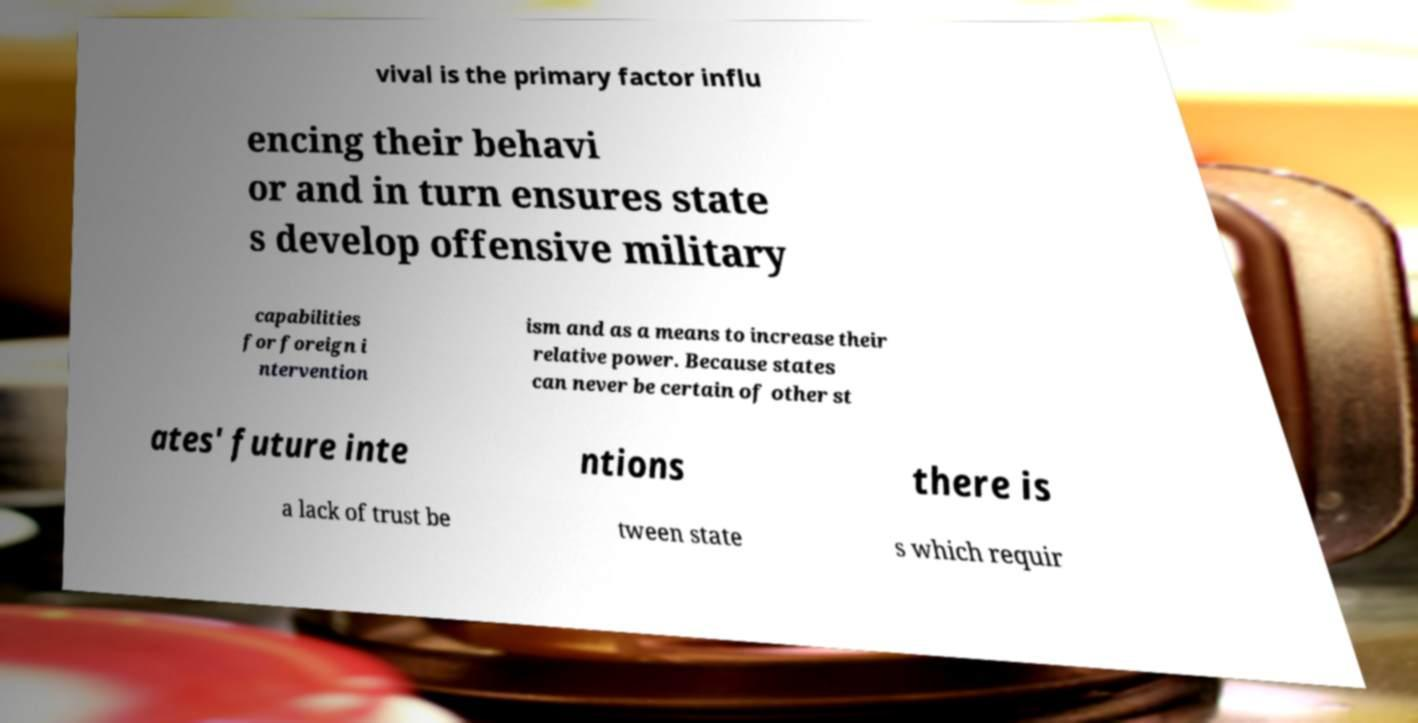For documentation purposes, I need the text within this image transcribed. Could you provide that? vival is the primary factor influ encing their behavi or and in turn ensures state s develop offensive military capabilities for foreign i ntervention ism and as a means to increase their relative power. Because states can never be certain of other st ates' future inte ntions there is a lack of trust be tween state s which requir 